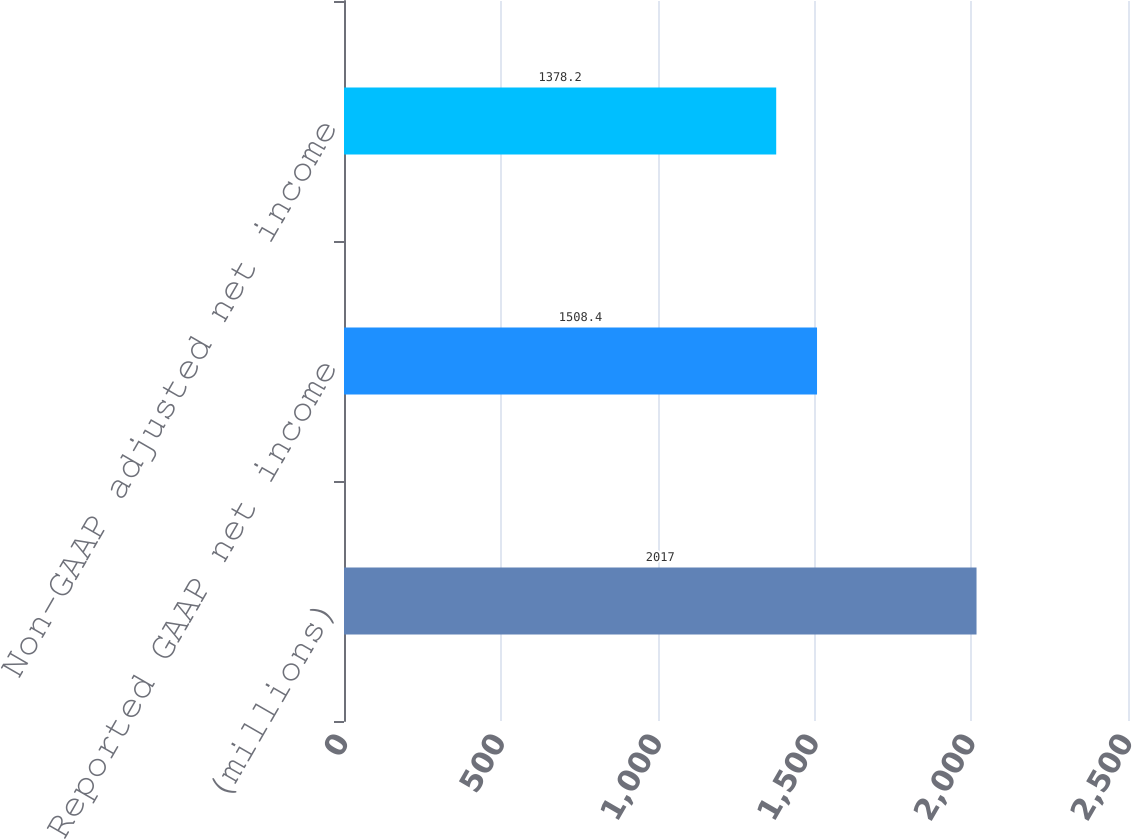<chart> <loc_0><loc_0><loc_500><loc_500><bar_chart><fcel>(millions)<fcel>Reported GAAP net income<fcel>Non-GAAP adjusted net income<nl><fcel>2017<fcel>1508.4<fcel>1378.2<nl></chart> 